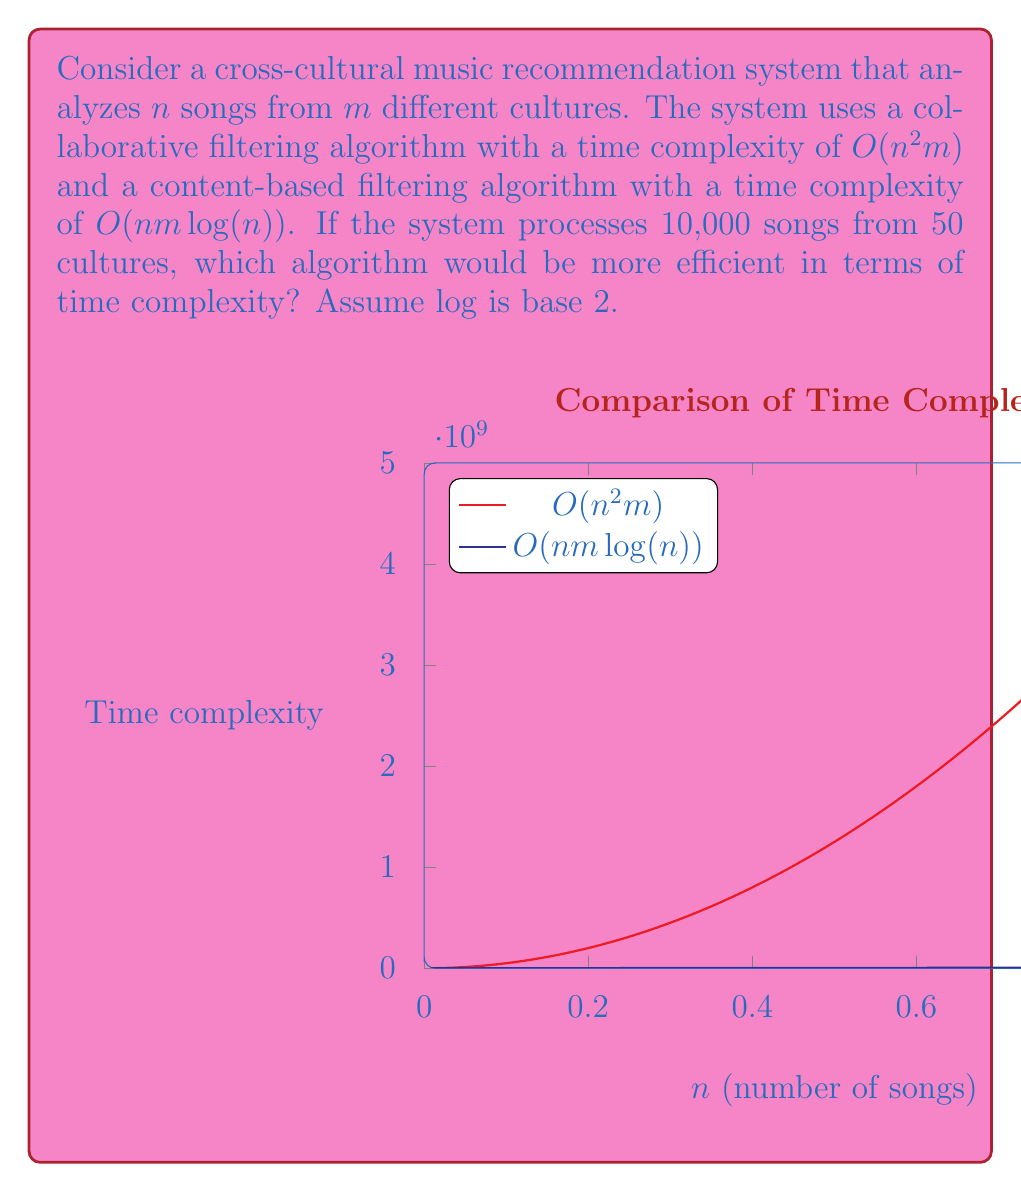Give your solution to this math problem. Let's approach this step-by-step:

1) We have $n = 10,000$ songs and $m = 50$ cultures.

2) For the collaborative filtering algorithm:
   Time complexity = $O(n^2m)$
   $= O((10,000)^2 * 50)$
   $= O(5 * 10^9)$

3) For the content-based filtering algorithm:
   Time complexity = $O(nm\log(n))$
   $= O(10,000 * 50 * \log_2(10,000))$
   $= O(500,000 * \log_2(10,000))$

4) To calculate $\log_2(10,000)$:
   $2^{13} = 8,192$ and $2^{14} = 16,384$
   So, $13 < \log_2(10,000) < 14$
   We can approximate $\log_2(10,000) \approx 13.29$

5) Therefore, for the content-based algorithm:
   Time complexity $\approx O(500,000 * 13.29)$
   $\approx O(6.645 * 10^6)$

6) Comparing the two:
   Collaborative filtering: $O(5 * 10^9)$
   Content-based filtering: $O(6.645 * 10^6)$

7) The content-based filtering algorithm has a lower time complexity for these input values.
Answer: Content-based filtering algorithm 